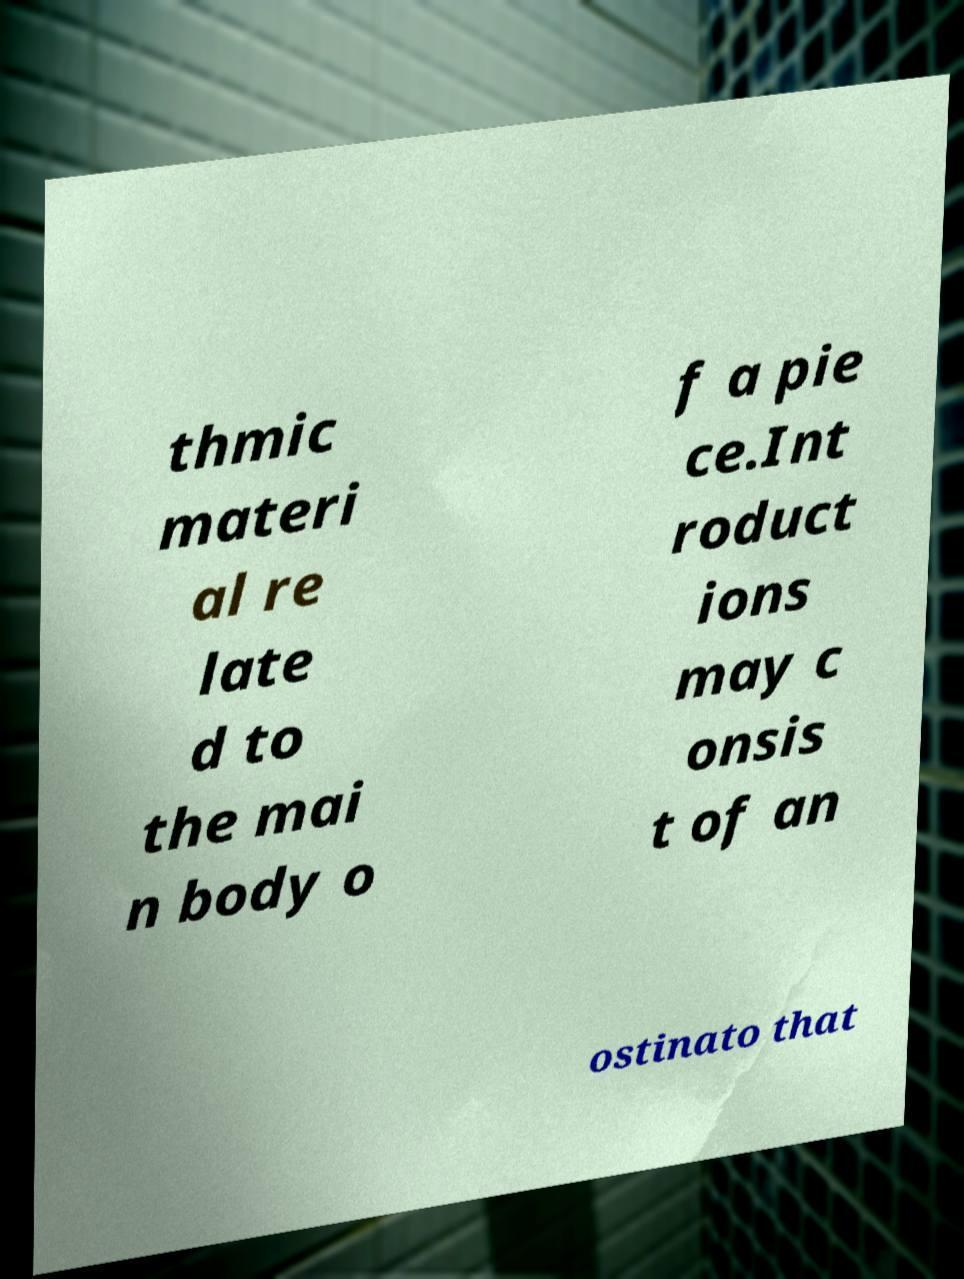Can you read and provide the text displayed in the image?This photo seems to have some interesting text. Can you extract and type it out for me? thmic materi al re late d to the mai n body o f a pie ce.Int roduct ions may c onsis t of an ostinato that 